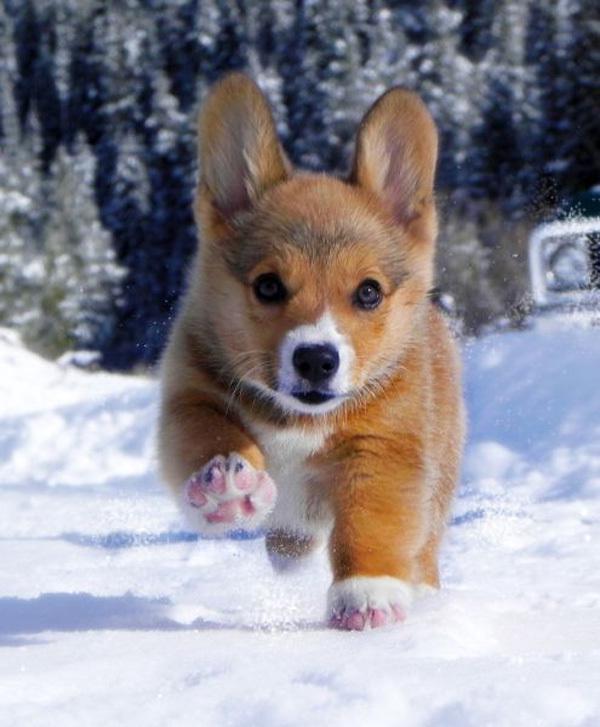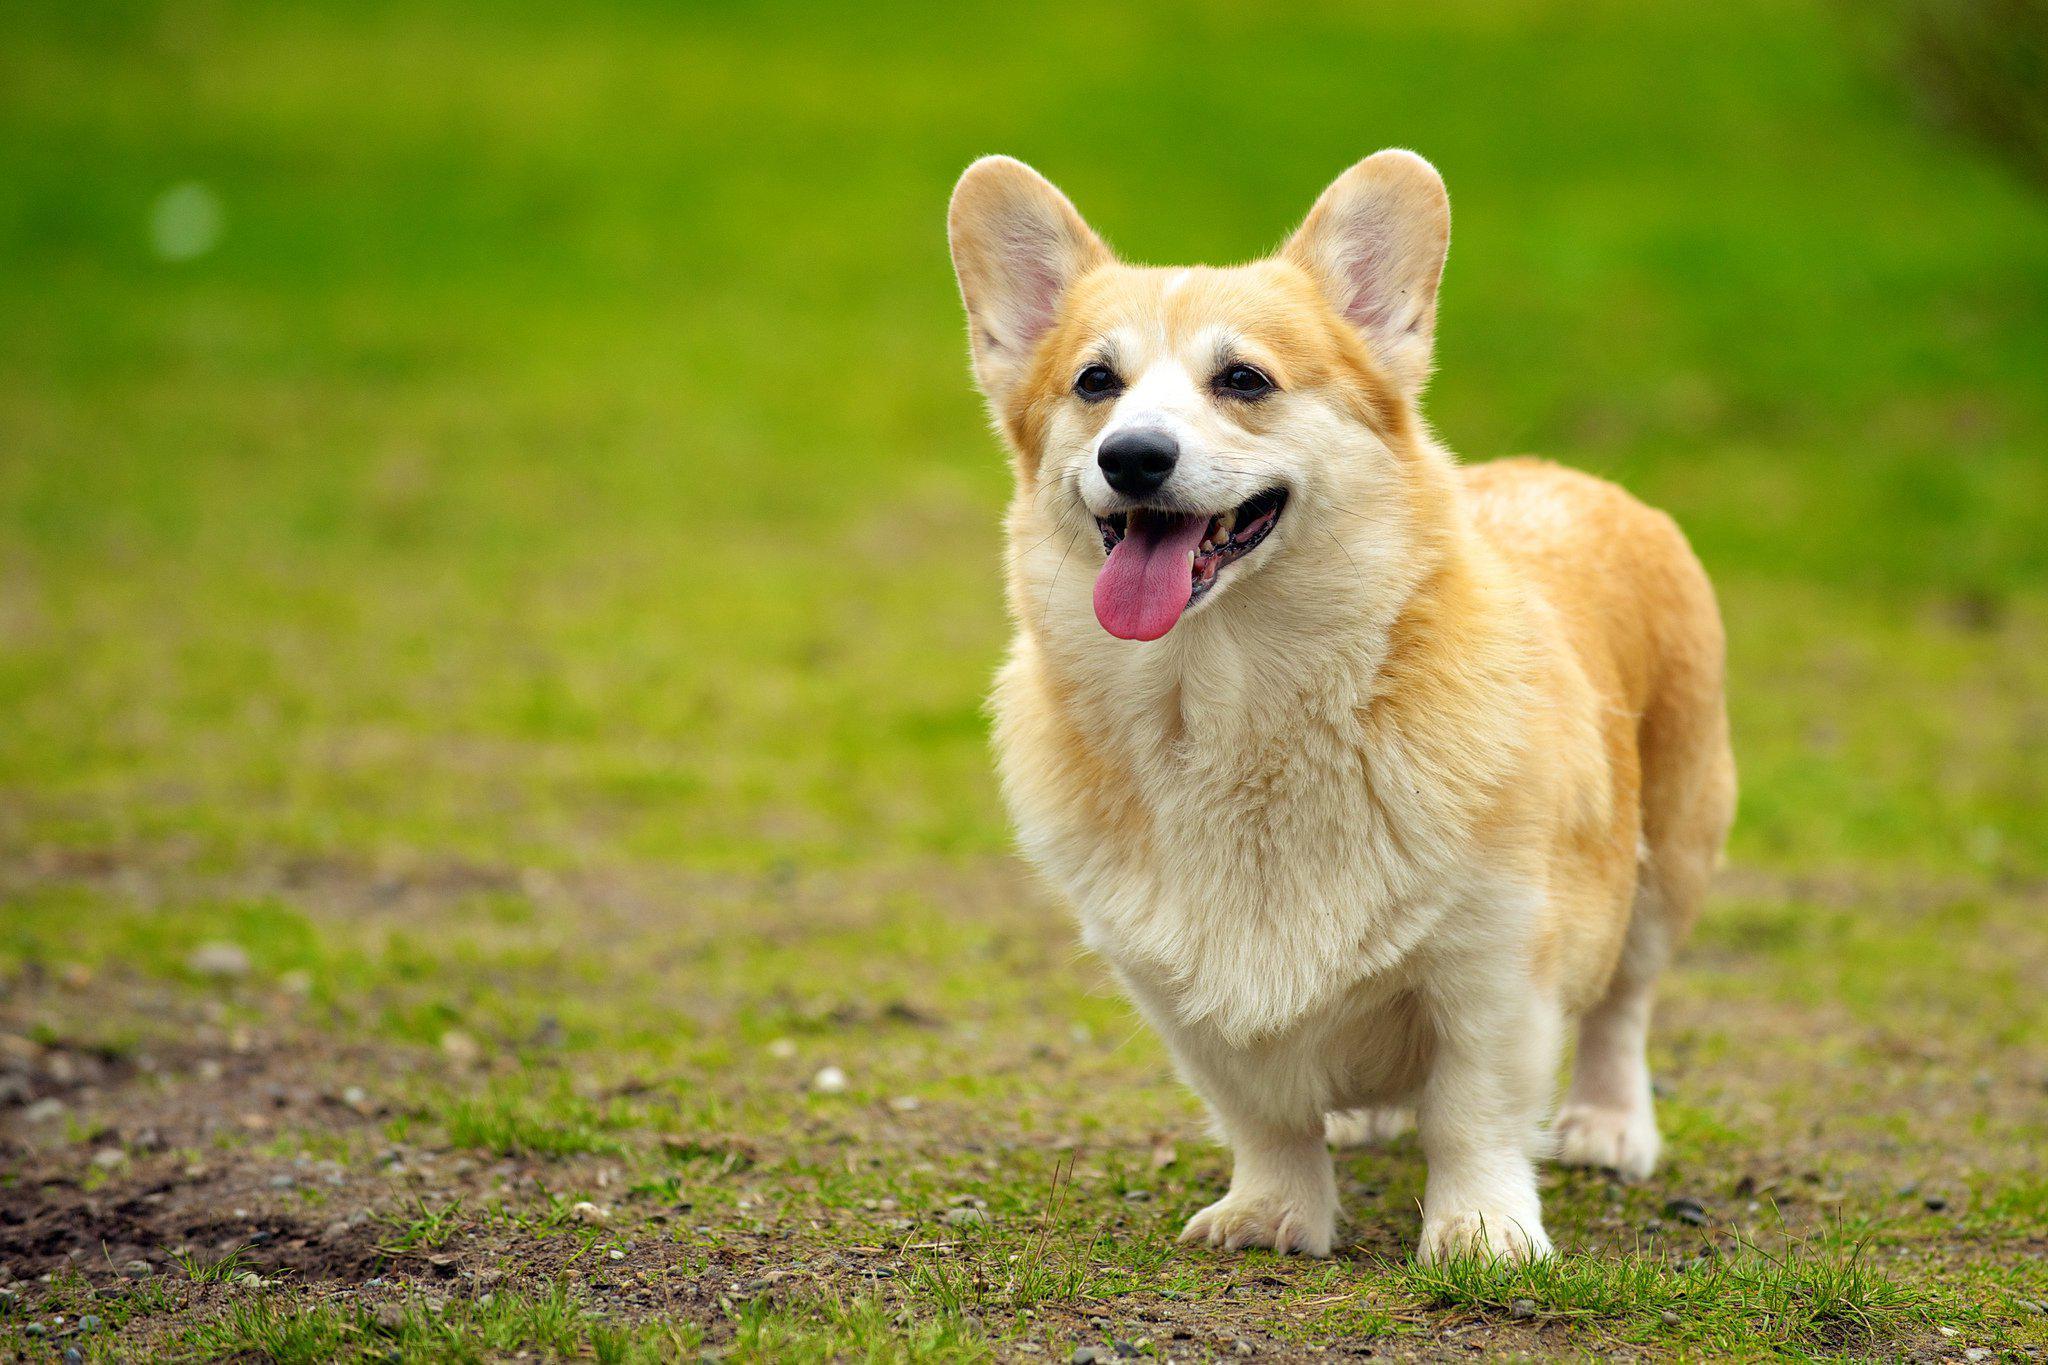The first image is the image on the left, the second image is the image on the right. Analyze the images presented: Is the assertion "In at least one image there is  a corgi white a black belly jumping in the are with it tongue wagging" valid? Answer yes or no. No. The first image is the image on the left, the second image is the image on the right. Given the left and right images, does the statement "One dog is in snow." hold true? Answer yes or no. Yes. 